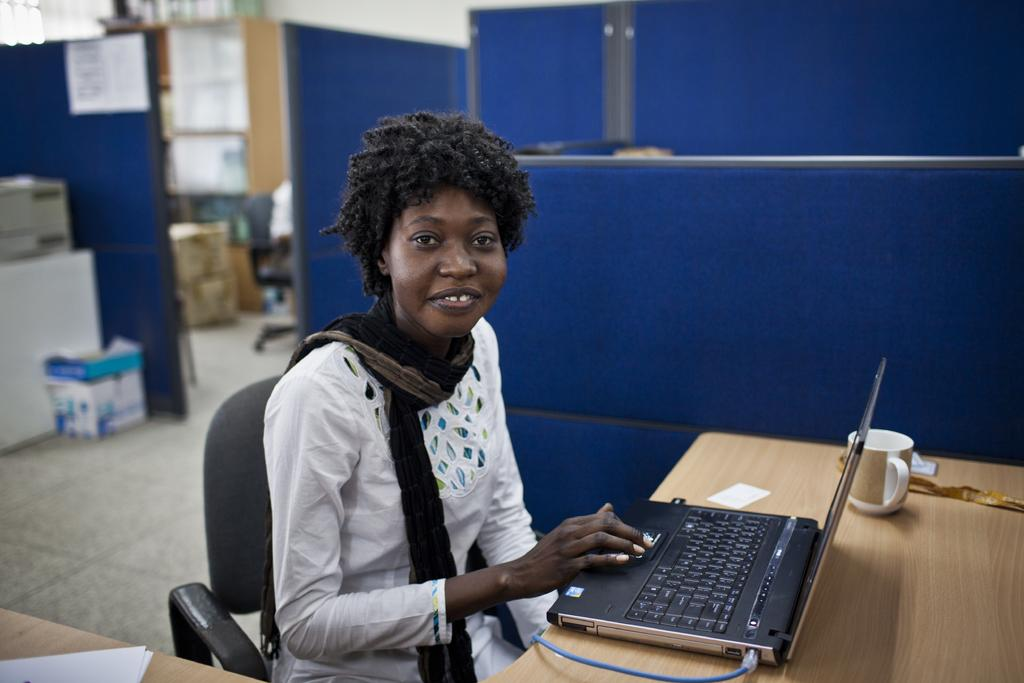What is on the table in the image? There is a laptop cup on the table in the image. What is the woman in the image doing? The woman is seated on a chair in front of the table. What can be seen in the background of the image? There are boxes and cupboards in the background. What type of animals can be seen at the zoo in the image? There is no zoo present in the image; it features a woman seated at a table with a laptop cup and a background with boxes and cupboards. 